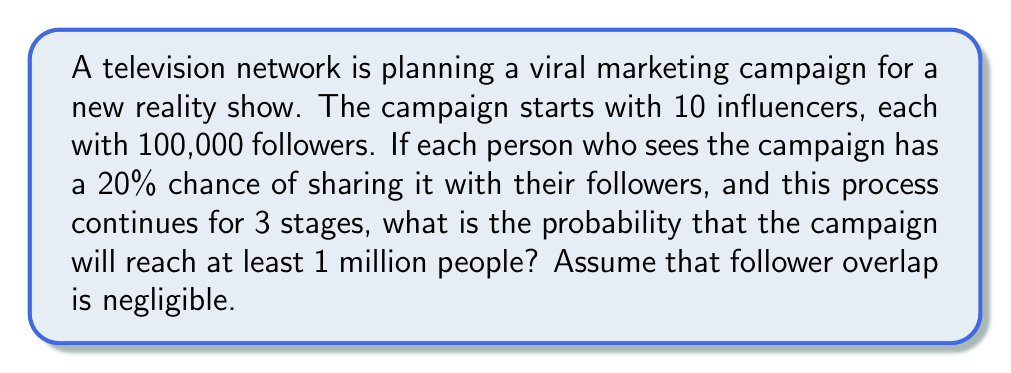Can you solve this math problem? Let's approach this step-by-step using a branching process model:

1) Initial reach: $10 \times 100,000 = 1,000,000$ people

2) For each stage, we can model the number of new shares as a binomial distribution:
   $X_i \sim B(n_i, 0.2)$, where $n_i$ is the number of people reached in the previous stage.

3) Expected number of new shares at each stage:
   Stage 1: $E[X_1] = 1,000,000 \times 0.2 = 200,000$
   Stage 2: $E[X_2] = 200,000 \times 0.2 = 40,000$
   Stage 3: $E[X_3] = 40,000 \times 0.2 = 8,000$

4) Total expected reach after 3 stages:
   $1,000,000 + 200,000 + 40,000 + 8,000 = 1,248,000$

5) To calculate the probability of reaching at least 1 million people, we can use the Central Limit Theorem to approximate the distribution of the total reach.

6) The variance of each stage:
   $Var(X_i) = n_i \times 0.2 \times 0.8$
   Stage 1: $Var(X_1) = 1,000,000 \times 0.2 \times 0.8 = 160,000$
   Stage 2: $Var(X_2) = 200,000 \times 0.2 \times 0.8 = 32,000$
   Stage 3: $Var(X_3) = 40,000 \times 0.2 \times 0.8 = 6,400$

7) Total variance: $160,000 + 32,000 + 6,400 = 198,400$

8) Standard deviation: $\sqrt{198,400} \approx 445.42$

9) Using the normal approximation:
   $Z = \frac{1,000,000 - 1,248,000}{445.42} \approx -556.76$

10) The probability of reaching at least 1 million people is:
    $P(X \geq 1,000,000) = 1 - P(Z < -556.76) \approx 1$

Therefore, the probability is essentially 1 (or >0.9999 to be more precise).
Answer: $\approx 1$ (or >0.9999) 